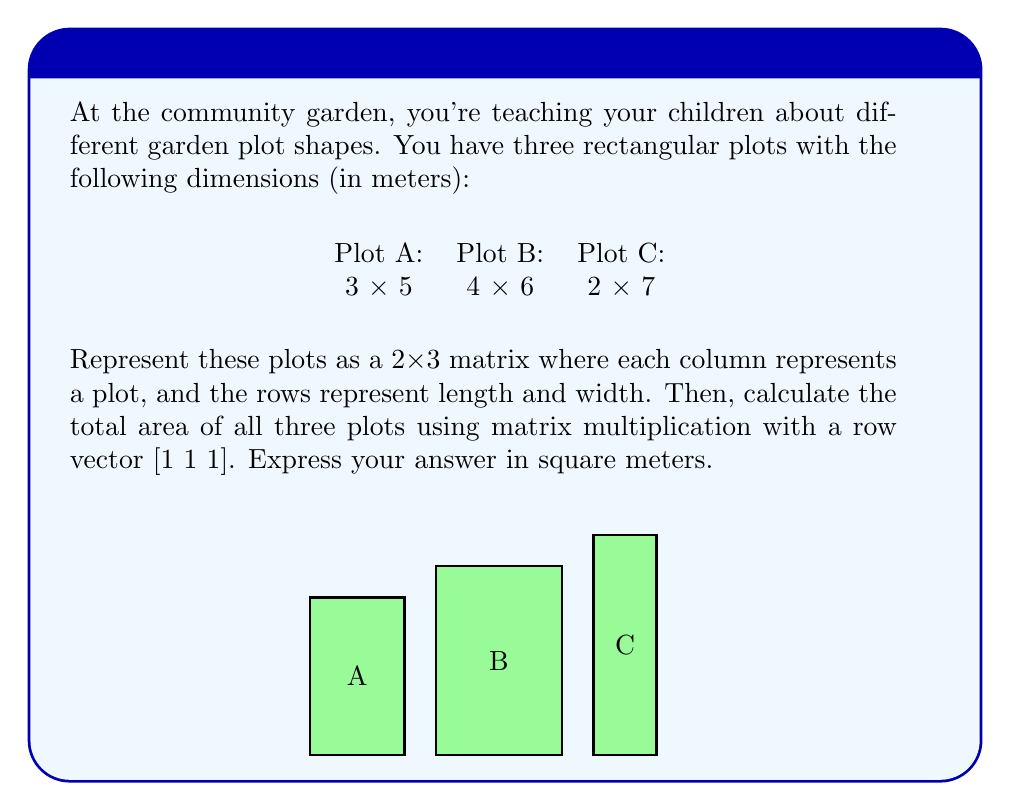Help me with this question. Let's approach this step-by-step:

1) First, we need to create our matrix. Each column represents a plot, and the rows represent length and width:

   $$A = \begin{bmatrix} 
   3 & 4 & 2 \\
   5 & 6 & 7
   \end{bmatrix}$$

2) To calculate the areas, we need to multiply each pair of numbers in each column. We can do this by creating a row vector [1 1 1] and multiplying it with our matrix:

   $$[1 \quad 1 \quad 1] \cdot \begin{bmatrix} 
   3 & 4 & 2 \\
   5 & 6 & 7
   \end{bmatrix}$$

3) Let's perform this multiplication:
   
   $[1(3) + 1(5) \quad 1(4) + 1(6) \quad 1(2) + 1(7)]$

4) Simplifying:

   $[8 \quad 10 \quad 9]$

5) These numbers represent the areas of each plot:
   - Plot A: 8 square meters
   - Plot B: 10 square meters
   - Plot C: 9 square meters

6) To get the total area, we sum these numbers:

   $8 + 10 + 9 = 27$

Therefore, the total area of all three plots is 27 square meters.
Answer: 27 sq m 